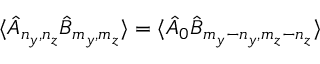Convert formula to latex. <formula><loc_0><loc_0><loc_500><loc_500>\langle \hat { A } _ { n _ { y } , n _ { z } } \hat { B } _ { m _ { y } , m _ { z } } \rangle = \langle \hat { A } _ { 0 } \hat { B } _ { m _ { y } - n _ { y } , m _ { z } - n _ { z } } \rangle</formula> 